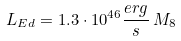Convert formula to latex. <formula><loc_0><loc_0><loc_500><loc_500>L _ { E d } = 1 . 3 \cdot 1 0 ^ { 4 6 } \frac { e r g } { s } \, M _ { 8 }</formula> 